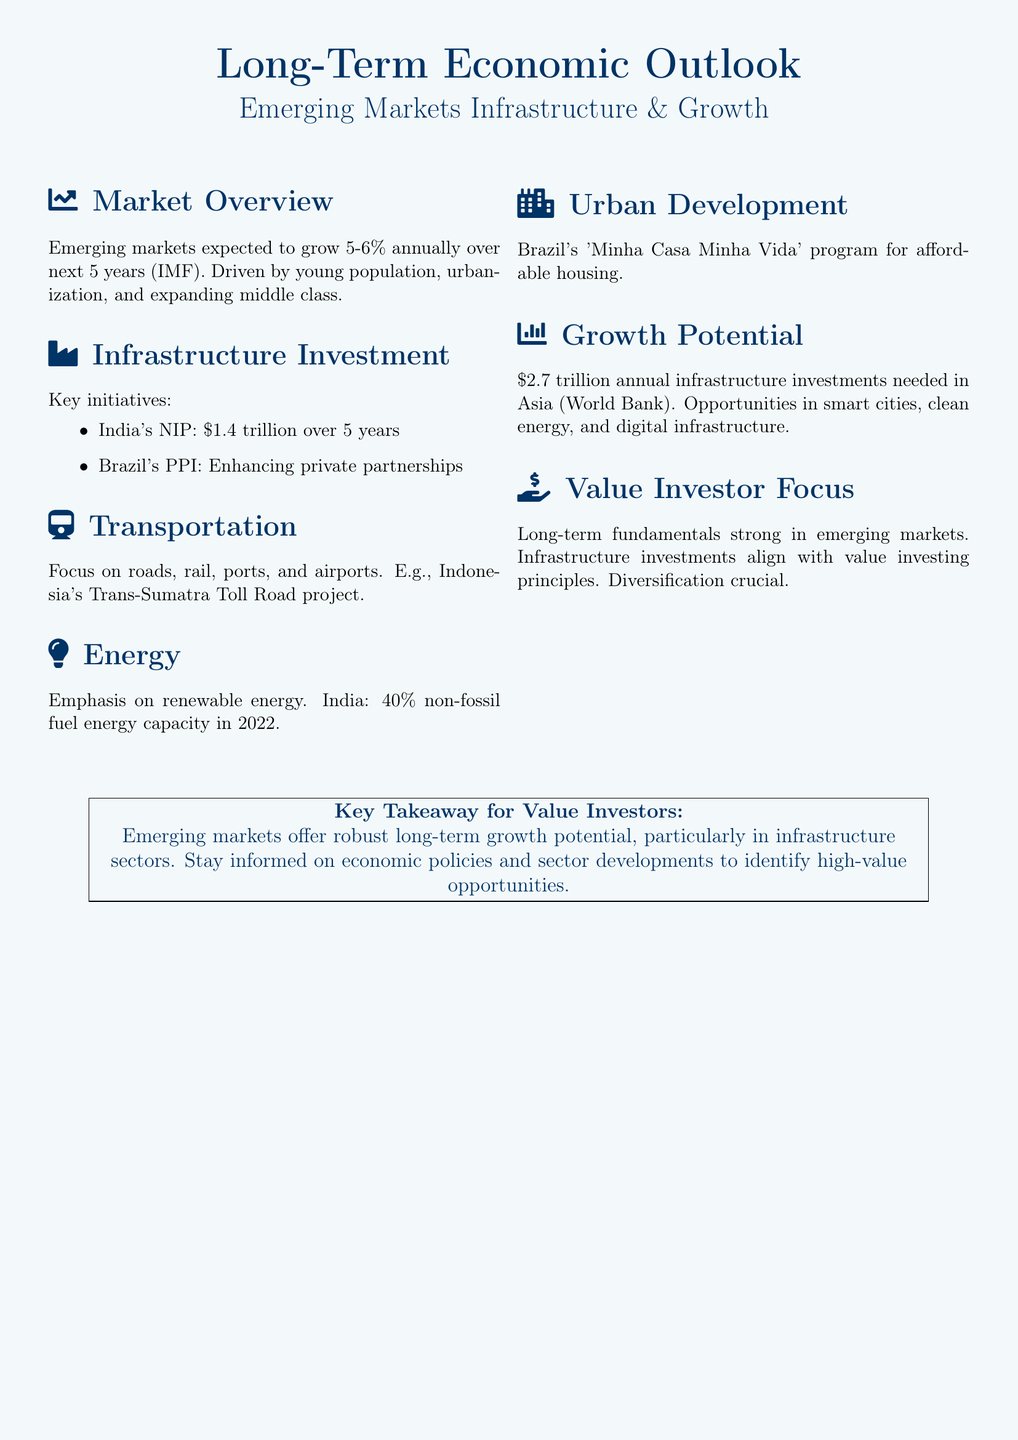What is the expected annual growth rate for emerging markets over the next 5 years? The document states that emerging markets are expected to grow 5-6% annually over the next 5 years as per the IMF.
Answer: 5-6% What is the investment amount for India's National Infrastructure Pipeline? The document lists India's National Infrastructure Pipeline as a key initiative with an investment of $1.4 trillion over 5 years.
Answer: $1.4 trillion Which country is enhancing private partnerships through its PPI? The document mentions Brazil's PPI as an initiative enhancing private partnerships.
Answer: Brazil What transportation project is highlighted in the document? The document highlights Indonesia's Trans-Sumatra Toll Road project as a focus area in the transportation section.
Answer: Trans-Sumatra Toll Road What percentage of India's energy capacity was non-fossil fuel in 2022? The document indicates that 40% of India's energy capacity was non-fossil fuel in 2022.
Answer: 40% What is the annual infrastructure investment needed in Asia according to the World Bank? The document states that $2.7 trillion annual infrastructure investments are needed in Asia according to the World Bank.
Answer: $2.7 trillion What program in Brazil aims for affordable housing? The document describes Brazil's 'Minha Casa Minha Vida' program aimed at providing affordable housing.
Answer: Minha Casa Minha Vida What does the key takeaway emphasize for value investors? The document's key takeaway emphasizes that emerging markets offer robust long-term growth potential, particularly in infrastructure sectors.
Answer: Robust long-term growth potential 